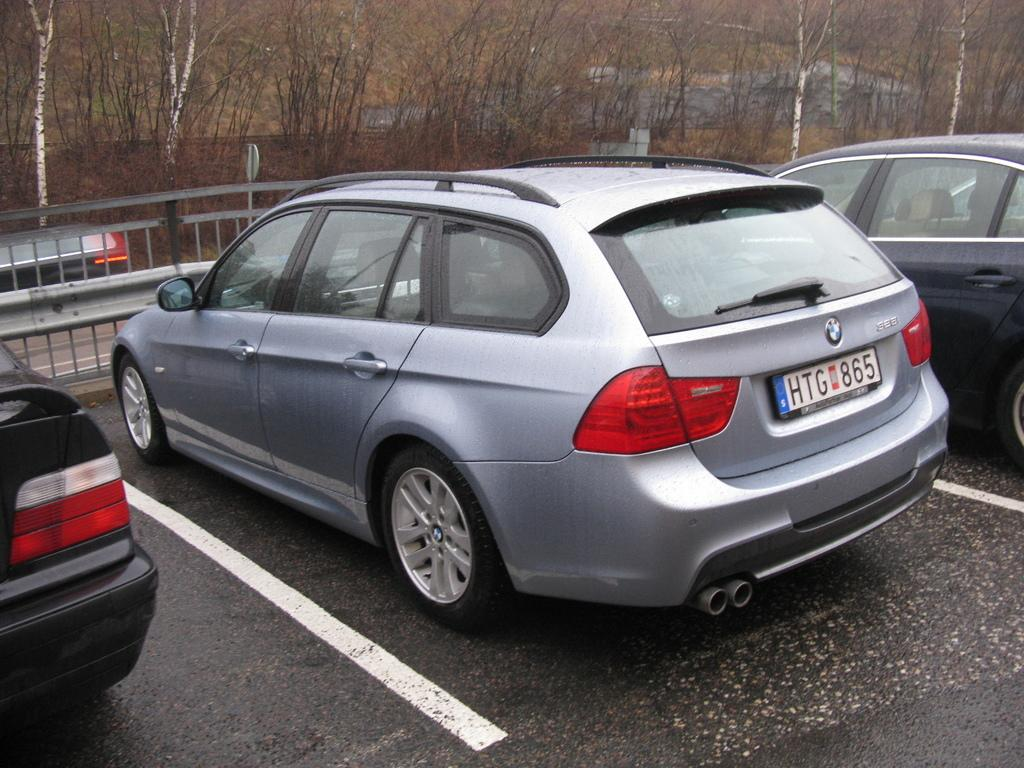What can be seen on the road in the image? There are cars on the road in the image. What is visible in the background of the image? There are fences, trees, and some unspecified objects in the background of the image. Where is the kitten playing with a frame and whistle in the image? There is no kitten, frame, or whistle present in the image. 